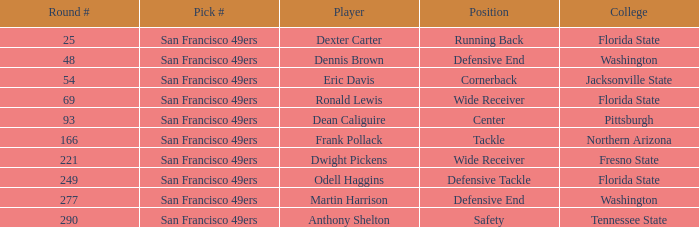What is the College with a Round # that is 290? Tennessee State. 